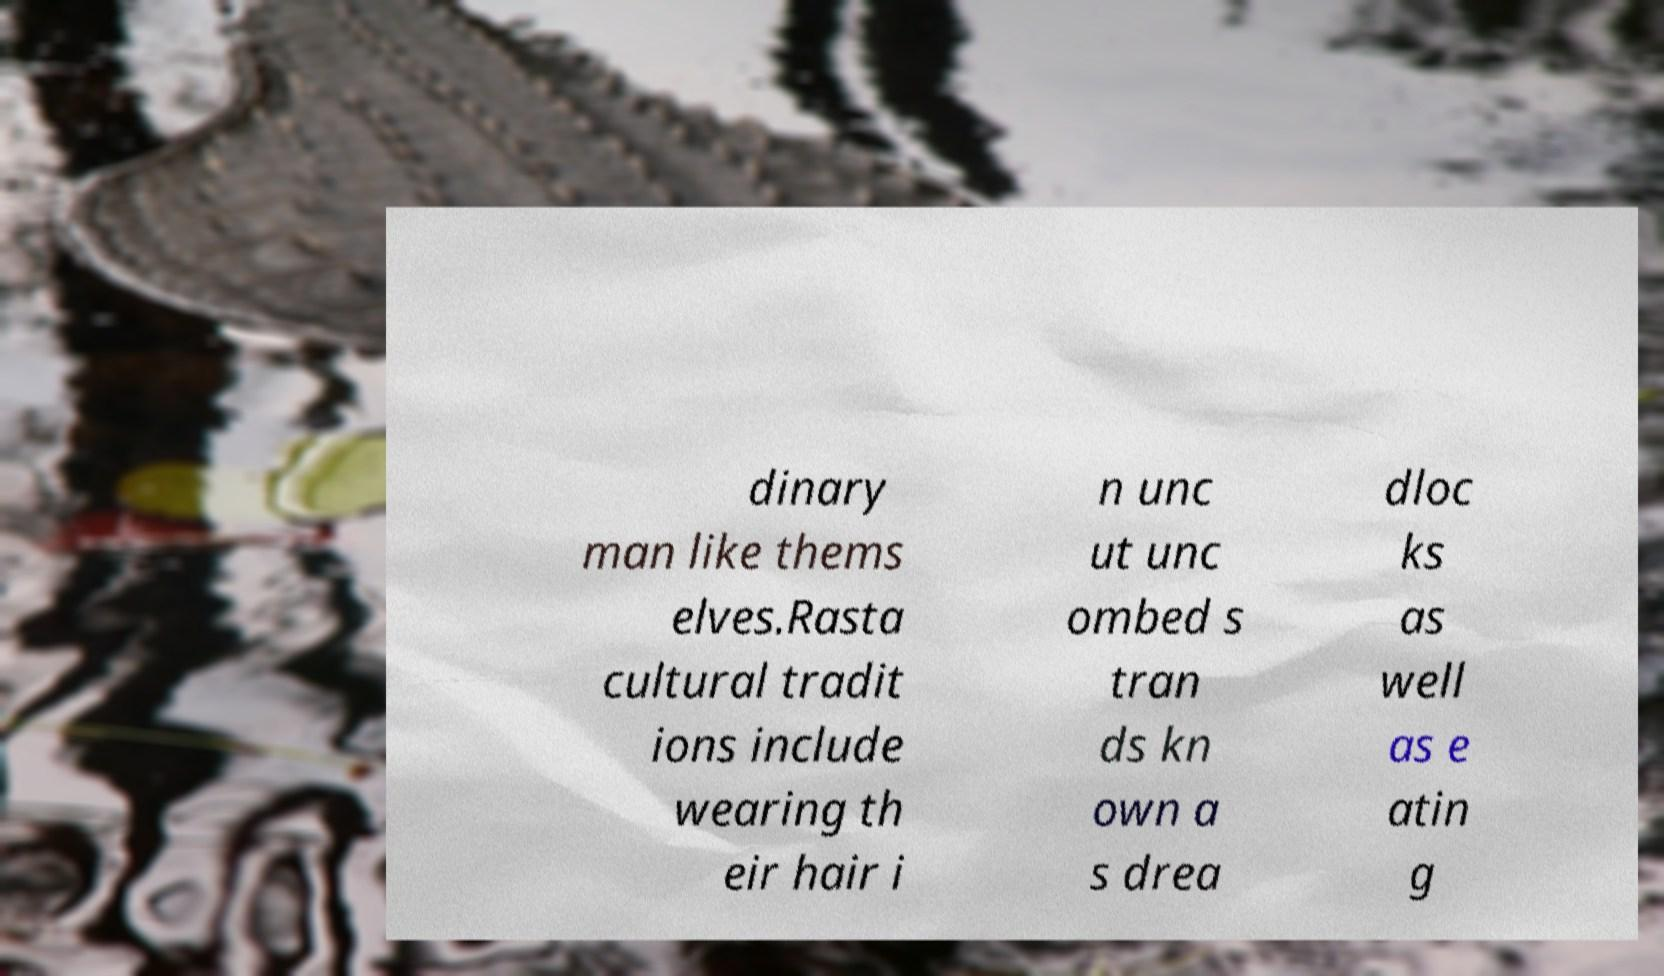Please read and relay the text visible in this image. What does it say? dinary man like thems elves.Rasta cultural tradit ions include wearing th eir hair i n unc ut unc ombed s tran ds kn own a s drea dloc ks as well as e atin g 